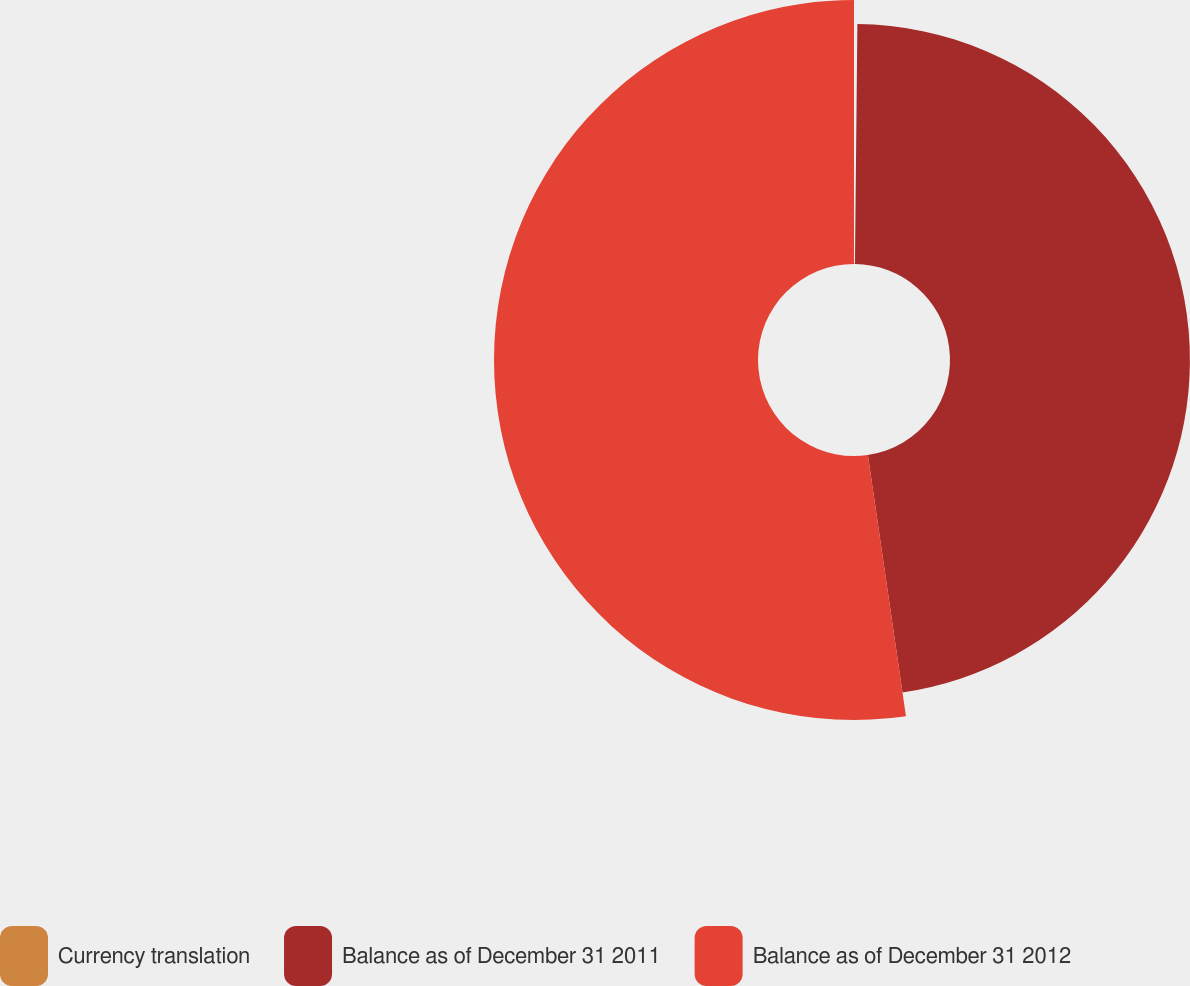<chart> <loc_0><loc_0><loc_500><loc_500><pie_chart><fcel>Currency translation<fcel>Balance as of December 31 2011<fcel>Balance as of December 31 2012<nl><fcel>0.16%<fcel>47.53%<fcel>52.3%<nl></chart> 